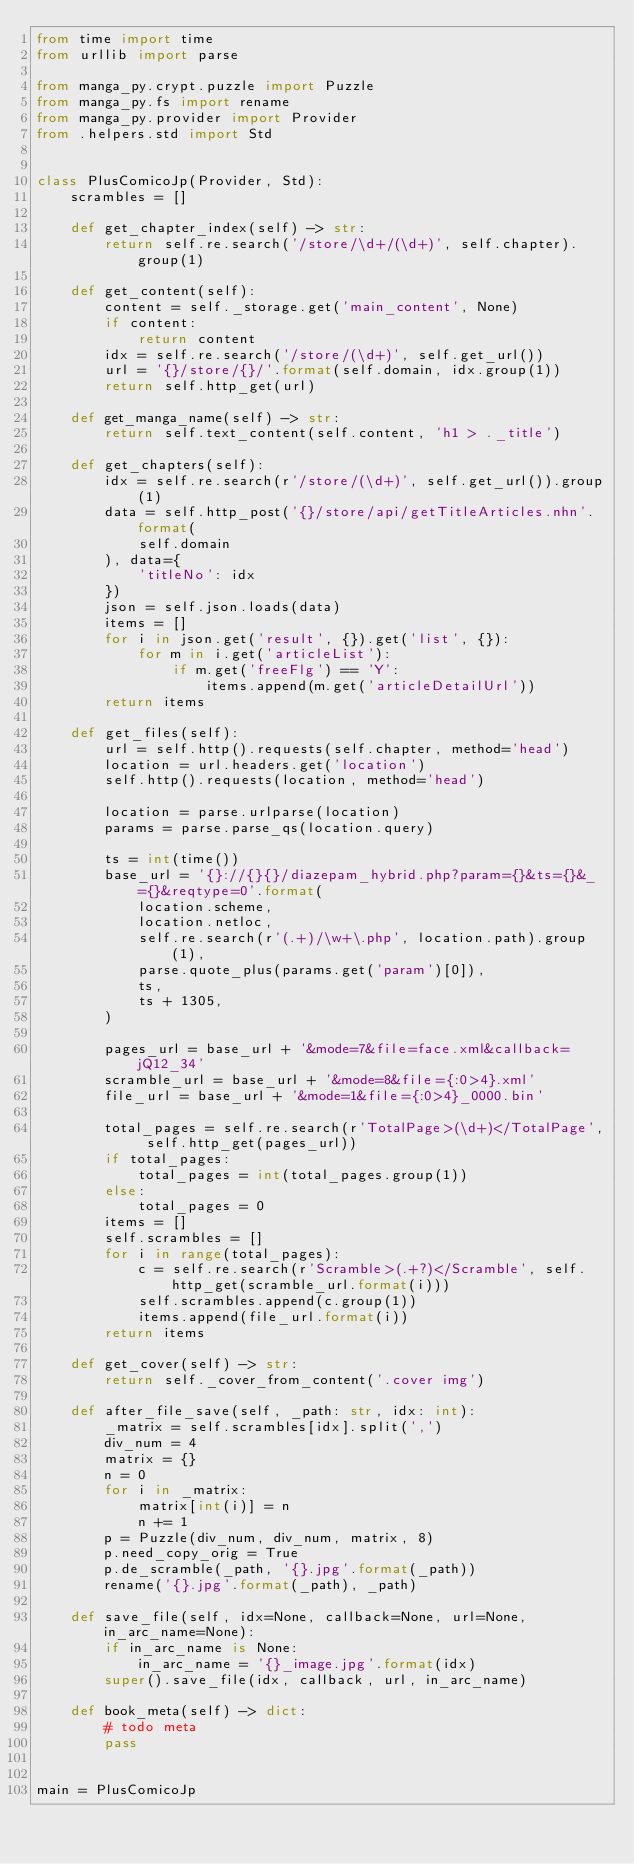Convert code to text. <code><loc_0><loc_0><loc_500><loc_500><_Python_>from time import time
from urllib import parse

from manga_py.crypt.puzzle import Puzzle
from manga_py.fs import rename
from manga_py.provider import Provider
from .helpers.std import Std


class PlusComicoJp(Provider, Std):
    scrambles = []

    def get_chapter_index(self) -> str:
        return self.re.search('/store/\d+/(\d+)', self.chapter).group(1)

    def get_content(self):
        content = self._storage.get('main_content', None)
        if content:
            return content
        idx = self.re.search('/store/(\d+)', self.get_url())
        url = '{}/store/{}/'.format(self.domain, idx.group(1))
        return self.http_get(url)

    def get_manga_name(self) -> str:
        return self.text_content(self.content, 'h1 > ._title')

    def get_chapters(self):
        idx = self.re.search(r'/store/(\d+)', self.get_url()).group(1)
        data = self.http_post('{}/store/api/getTitleArticles.nhn'.format(
            self.domain
        ), data={
            'titleNo': idx
        })
        json = self.json.loads(data)
        items = []
        for i in json.get('result', {}).get('list', {}):
            for m in i.get('articleList'):
                if m.get('freeFlg') == 'Y':
                    items.append(m.get('articleDetailUrl'))
        return items

    def get_files(self):
        url = self.http().requests(self.chapter, method='head')
        location = url.headers.get('location')
        self.http().requests(location, method='head')

        location = parse.urlparse(location)
        params = parse.parse_qs(location.query)

        ts = int(time())
        base_url = '{}://{}{}/diazepam_hybrid.php?param={}&ts={}&_={}&reqtype=0'.format(
            location.scheme,
            location.netloc,
            self.re.search(r'(.+)/\w+\.php', location.path).group(1),
            parse.quote_plus(params.get('param')[0]),
            ts,
            ts + 1305,
        )

        pages_url = base_url + '&mode=7&file=face.xml&callback=jQ12_34'
        scramble_url = base_url + '&mode=8&file={:0>4}.xml'
        file_url = base_url + '&mode=1&file={:0>4}_0000.bin'

        total_pages = self.re.search(r'TotalPage>(\d+)</TotalPage', self.http_get(pages_url))
        if total_pages:
            total_pages = int(total_pages.group(1))
        else:
            total_pages = 0
        items = []
        self.scrambles = []
        for i in range(total_pages):
            c = self.re.search(r'Scramble>(.+?)</Scramble', self.http_get(scramble_url.format(i)))
            self.scrambles.append(c.group(1))
            items.append(file_url.format(i))
        return items

    def get_cover(self) -> str:
        return self._cover_from_content('.cover img')

    def after_file_save(self, _path: str, idx: int):
        _matrix = self.scrambles[idx].split(',')
        div_num = 4
        matrix = {}
        n = 0
        for i in _matrix:
            matrix[int(i)] = n
            n += 1
        p = Puzzle(div_num, div_num, matrix, 8)
        p.need_copy_orig = True
        p.de_scramble(_path, '{}.jpg'.format(_path))
        rename('{}.jpg'.format(_path), _path)

    def save_file(self, idx=None, callback=None, url=None, in_arc_name=None):
        if in_arc_name is None:
            in_arc_name = '{}_image.jpg'.format(idx)
        super().save_file(idx, callback, url, in_arc_name)

    def book_meta(self) -> dict:
        # todo meta
        pass


main = PlusComicoJp
</code> 